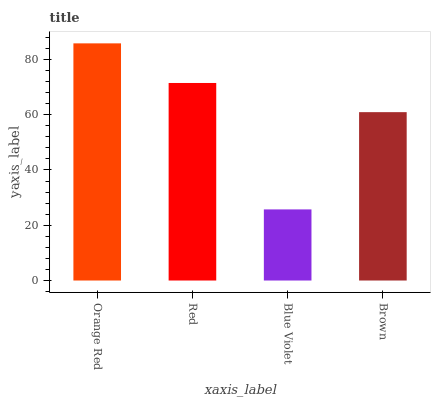Is Blue Violet the minimum?
Answer yes or no. Yes. Is Orange Red the maximum?
Answer yes or no. Yes. Is Red the minimum?
Answer yes or no. No. Is Red the maximum?
Answer yes or no. No. Is Orange Red greater than Red?
Answer yes or no. Yes. Is Red less than Orange Red?
Answer yes or no. Yes. Is Red greater than Orange Red?
Answer yes or no. No. Is Orange Red less than Red?
Answer yes or no. No. Is Red the high median?
Answer yes or no. Yes. Is Brown the low median?
Answer yes or no. Yes. Is Brown the high median?
Answer yes or no. No. Is Blue Violet the low median?
Answer yes or no. No. 